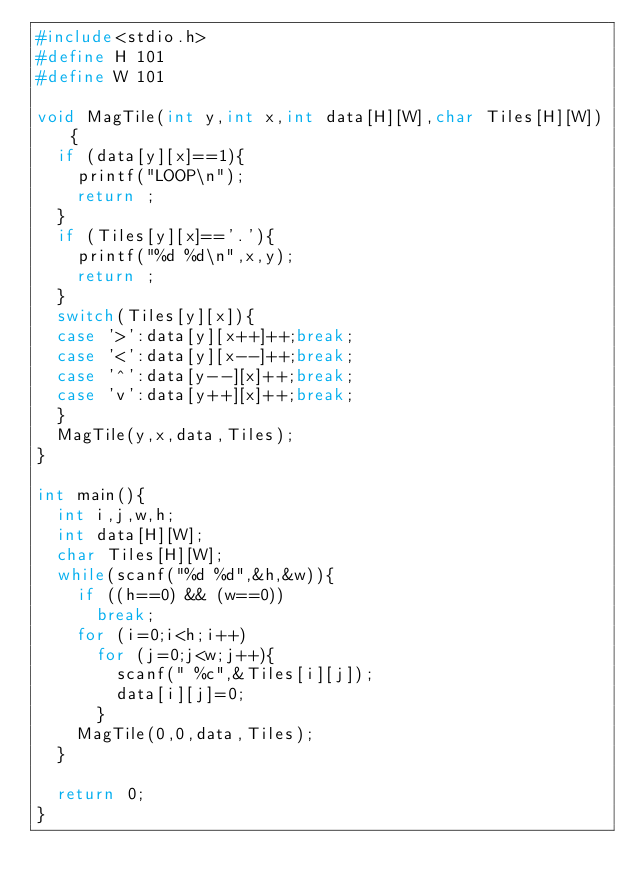<code> <loc_0><loc_0><loc_500><loc_500><_C_>#include<stdio.h>
#define H 101
#define W 101

void MagTile(int y,int x,int data[H][W],char Tiles[H][W]){
  if (data[y][x]==1){
    printf("LOOP\n");
    return ;
  }
  if (Tiles[y][x]=='.'){
    printf("%d %d\n",x,y);
    return ;
  }
  switch(Tiles[y][x]){
  case '>':data[y][x++]++;break;
  case '<':data[y][x--]++;break;
  case '^':data[y--][x]++;break;
  case 'v':data[y++][x]++;break;
  }
  MagTile(y,x,data,Tiles);
}

int main(){
  int i,j,w,h;
  int data[H][W];
  char Tiles[H][W];
  while(scanf("%d %d",&h,&w)){
    if ((h==0) && (w==0))
      break;
    for (i=0;i<h;i++)
      for (j=0;j<w;j++){
        scanf(" %c",&Tiles[i][j]);
        data[i][j]=0;
      }
    MagTile(0,0,data,Tiles);
  }

  return 0;
}</code> 